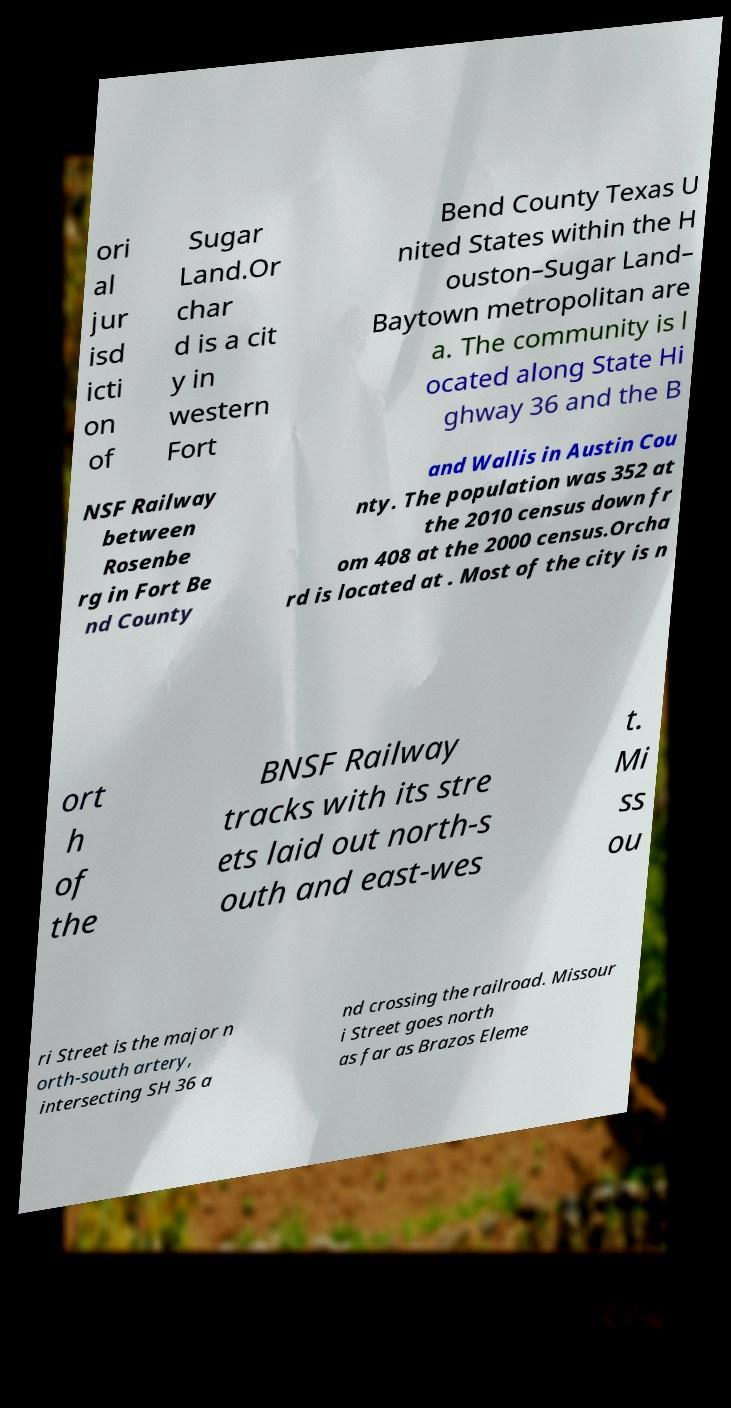Please read and relay the text visible in this image. What does it say? ori al jur isd icti on of Sugar Land.Or char d is a cit y in western Fort Bend County Texas U nited States within the H ouston–Sugar Land– Baytown metropolitan are a. The community is l ocated along State Hi ghway 36 and the B NSF Railway between Rosenbe rg in Fort Be nd County and Wallis in Austin Cou nty. The population was 352 at the 2010 census down fr om 408 at the 2000 census.Orcha rd is located at . Most of the city is n ort h of the BNSF Railway tracks with its stre ets laid out north-s outh and east-wes t. Mi ss ou ri Street is the major n orth-south artery, intersecting SH 36 a nd crossing the railroad. Missour i Street goes north as far as Brazos Eleme 